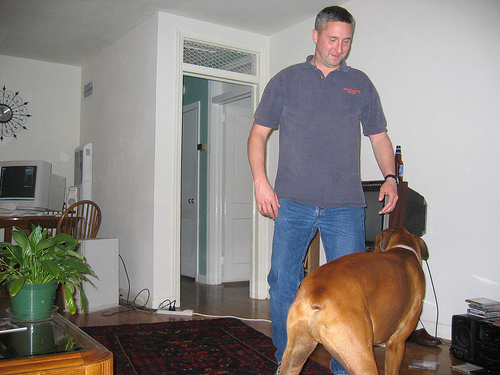<image>
Is there a man behind the dog? Yes. From this viewpoint, the man is positioned behind the dog, with the dog partially or fully occluding the man. Is the dog behind the man? No. The dog is not behind the man. From this viewpoint, the dog appears to be positioned elsewhere in the scene. Is the man in front of the dog? No. The man is not in front of the dog. The spatial positioning shows a different relationship between these objects. 